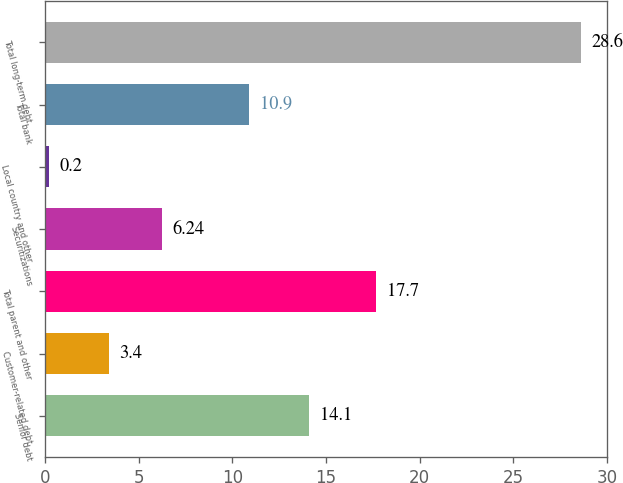Convert chart. <chart><loc_0><loc_0><loc_500><loc_500><bar_chart><fcel>Senior debt<fcel>Customer-related debt<fcel>Total parent and other<fcel>Securitizations<fcel>Local country and other<fcel>Total bank<fcel>Total long-term debt<nl><fcel>14.1<fcel>3.4<fcel>17.7<fcel>6.24<fcel>0.2<fcel>10.9<fcel>28.6<nl></chart> 